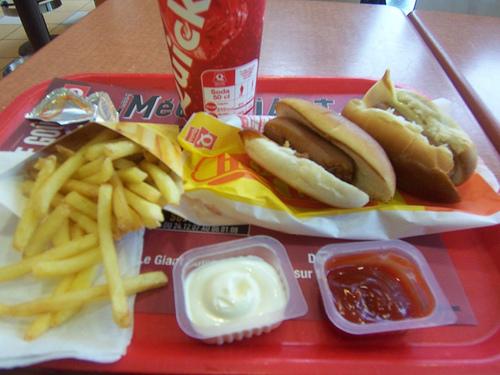How many hot dogs are there?
Concise answer only. 2. What color is the table?
Quick response, please. Brown. What condiments are in this picture?
Concise answer only. Mayo and ketchup. What are the pictures on the table?
Answer briefly. Food. 